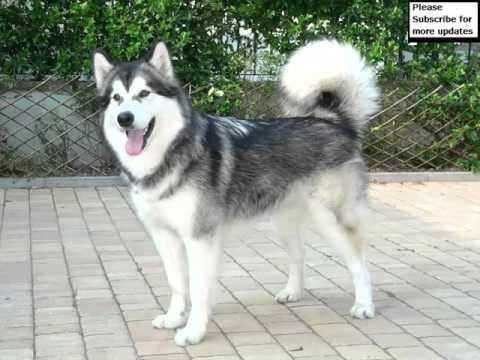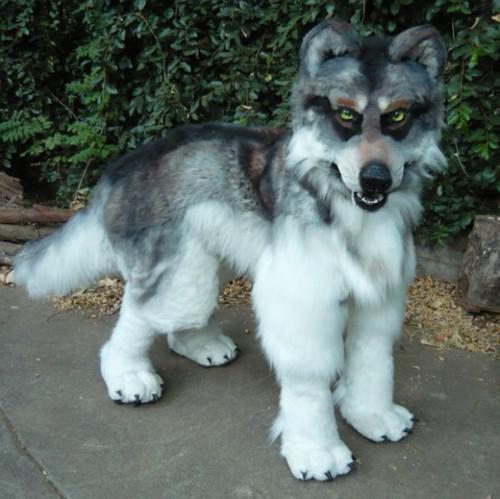The first image is the image on the left, the second image is the image on the right. Evaluate the accuracy of this statement regarding the images: "Each image shows one dog standing still with its body mostly in profile, and at least one dog has an upturned curled tail.". Is it true? Answer yes or no. Yes. 